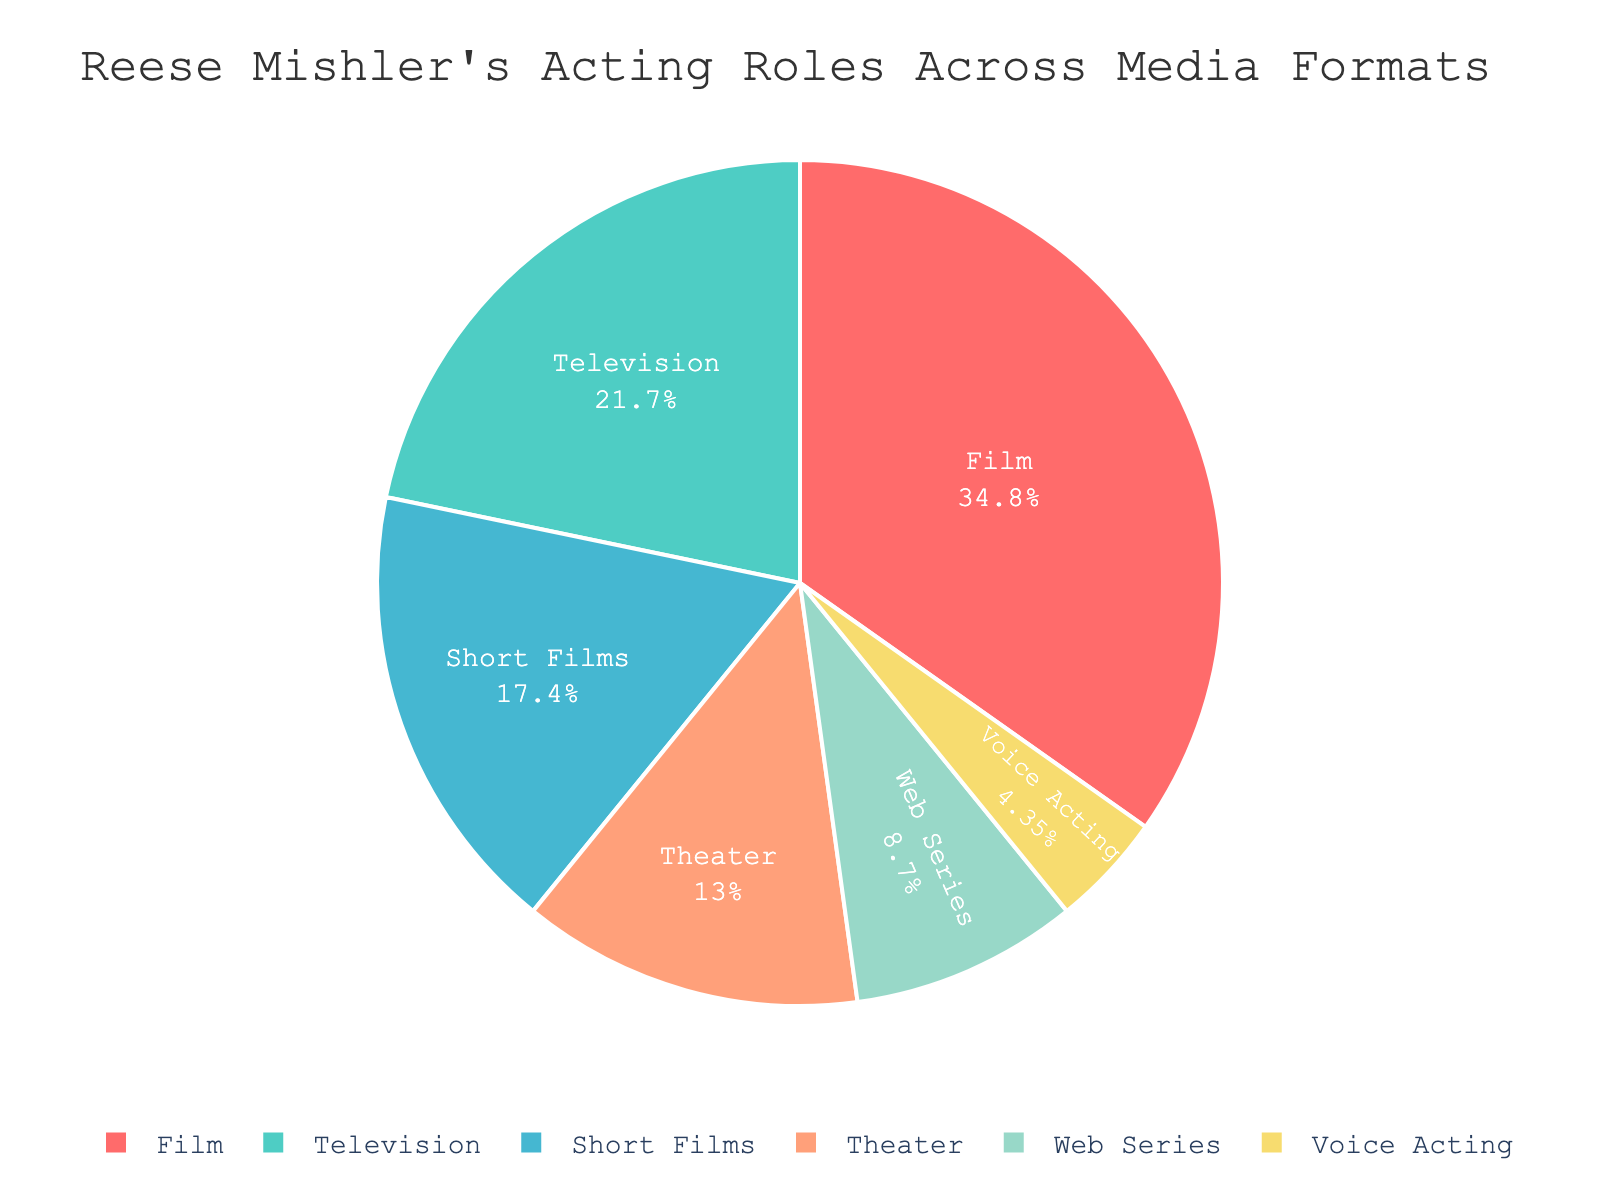What's the percentage of Reese Mishler's roles in films? By looking at the figure, each slice of the pie chart represents a different media format. The slice labeled 'Film' shows Reese Mishler performed 8 roles. The percentage is calculated as (8 roles / total roles) * 100. The total number of roles is 8 (Film) + 5 (Television) + 3 (Theater) + 2 (Web Series) + 4 (Short Films) + 1 (Voice Acting) = 23. So, (8/23) * 100 ≈ 34.78%.
Answer: 34.78% How does the number of roles in television compare to those in theater? The pie chart shows the roles in television as 5 and in theater as 3. By comparing these two numbers, we find that Reese Mishler has taken more roles in television (5) compared to theater (3).
Answer: More in television What is the combined percentage of Reese Mishler's roles in web series and voice acting? The pie chart indicates the number of roles in web series as 2 and in voice acting as 1. The combined number of roles is 2 + 1 = 3. The total number of roles is 23. The combined percentage is (3/23) * 100 ≈ 13.04%.
Answer: 13.04% Which media format has the smallest representation in Reese Mishler's acting career? By looking at the slices of the pie chart, the smallest slice corresponds to 'Voice Acting', with only 1 role.
Answer: Voice Acting How many more roles does Reese Mishler have in films than in short films? Reese Mishler has 8 roles in films and 4 roles in short films. The difference is 8 - 4 = 4.
Answer: 4 more roles Does Reese Mishler have more roles in films than the combined roles in web series and voice acting? Reese Mishler has 8 roles in films. The combined number of roles in web series and voice acting is 2 + 1 = 3. Since 8 is greater than 3, he has more roles in films.
Answer: Yes What is the total number of roles in formats other than films? The total number of roles in other formats is calculated as the sum of roles in television (5), theater (3), web series (2), short films (4), and voice acting (1). So, 5 + 3 + 2 + 4 + 1 = 15.
Answer: 15 What percentage of Reese Mishler's roles are in theater compared to the total roles? The pie chart shows that Reese Mishler performed 3 roles in theater. The total number of roles is 23. The percentage is (3/23) * 100 ≈ 13.04%.
Answer: 13.04% 